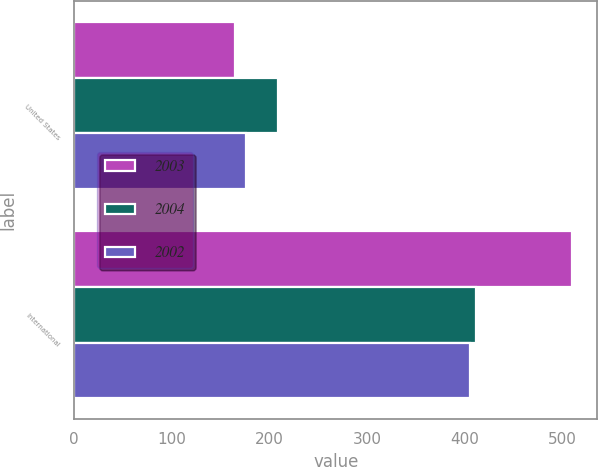Convert chart to OTSL. <chart><loc_0><loc_0><loc_500><loc_500><stacked_bar_chart><ecel><fcel>United States<fcel>International<nl><fcel>2003<fcel>164.6<fcel>510.7<nl><fcel>2004<fcel>209.2<fcel>411.4<nl><fcel>2002<fcel>176.5<fcel>405.5<nl></chart> 